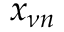Convert formula to latex. <formula><loc_0><loc_0><loc_500><loc_500>x _ { \nu n }</formula> 